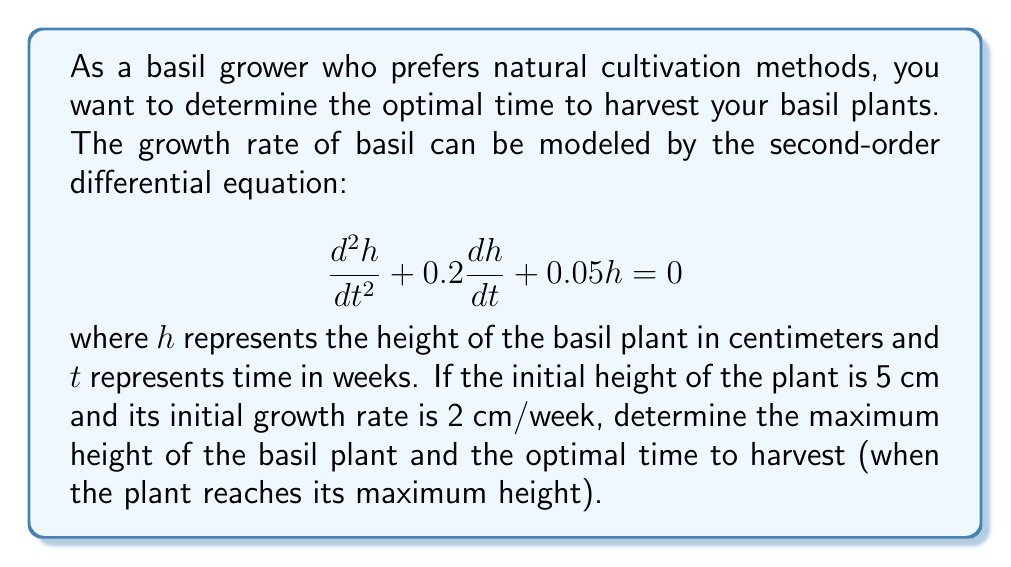Teach me how to tackle this problem. To solve this problem, we'll follow these steps:

1) First, we need to solve the second-order differential equation. The characteristic equation is:

   $$r^2 + 0.2r + 0.05 = 0$$

2) Solving this quadratic equation:

   $$r = \frac{-0.2 \pm \sqrt{0.2^2 - 4(1)(0.05)}}{2(1)} = -0.1 \pm 0.1i$$

3) Therefore, the general solution is:

   $$h(t) = e^{-0.1t}(A\cos(0.1t) + B\sin(0.1t))$$

4) Using the initial conditions:
   
   At $t=0$, $h(0) = 5$ and $h'(0) = 2$

5) From $h(0) = 5$:

   $$5 = A$$

6) From $h'(0) = 2$:

   $$h'(t) = e^{-0.1t}((-0.1A + 0.1B)\cos(0.1t) + (-0.1B - 0.1A)\sin(0.1t))$$
   $$2 = -0.1A + 0.1B$$
   $$2 = -0.5 + 0.1B$$
   $$B = 25$$

7) Therefore, the particular solution is:

   $$h(t) = e^{-0.1t}(5\cos(0.1t) + 25\sin(0.1t))$$

8) To find the maximum height, we need to find when $h'(t) = 0$:

   $$h'(t) = e^{-0.1t}(-0.5\cos(0.1t) - 0.5\sin(0.1t) + 2.5\cos(0.1t) - 2.5\sin(0.1t))$$
   $$h'(t) = e^{-0.1t}(2\cos(0.1t) - 3\sin(0.1t))$$

9) Setting this equal to zero:

   $$2\cos(0.1t) - 3\sin(0.1t) = 0$$
   $$\tan(0.1t) = \frac{2}{3}$$
   $$t = \frac{1}{0.1}\arctan(\frac{2}{3}) \approx 5.89 \text{ weeks}$$

10) The maximum height occurs at this time:

    $$h(5.89) \approx 25.14 \text{ cm}$$

Therefore, the optimal time to harvest is approximately 5.89 weeks after planting, when the basil plant reaches its maximum height of about 25.14 cm.
Answer: The maximum height of the basil plant is approximately 25.14 cm, and the optimal time to harvest is approximately 5.89 weeks after planting. 